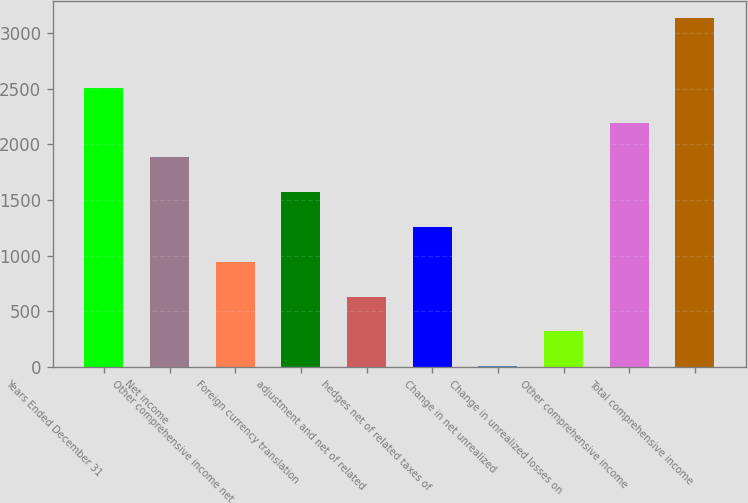Convert chart. <chart><loc_0><loc_0><loc_500><loc_500><bar_chart><fcel>Years Ended December 31<fcel>Net income<fcel>Other comprehensive income net<fcel>Foreign currency translation<fcel>adjustment and net of related<fcel>hedges net of related taxes of<fcel>Change in net unrealized<fcel>Change in unrealized losses on<fcel>Other comprehensive income<fcel>Total comprehensive income<nl><fcel>2507<fcel>1882<fcel>944.5<fcel>1569.5<fcel>632<fcel>1257<fcel>7<fcel>319.5<fcel>2194.5<fcel>3132<nl></chart> 